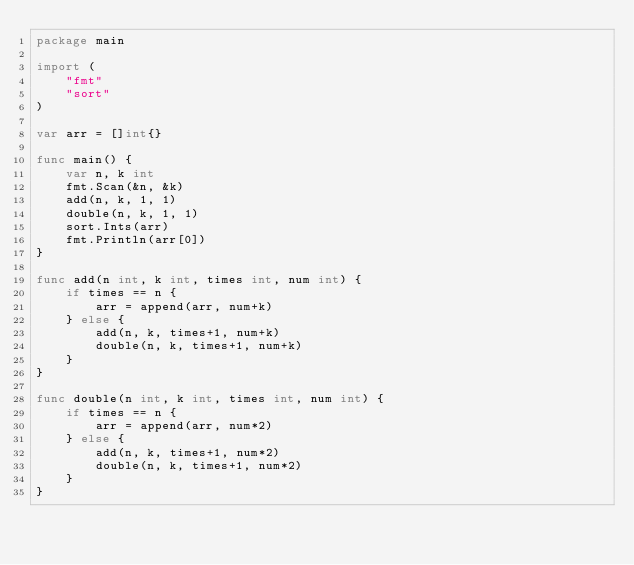Convert code to text. <code><loc_0><loc_0><loc_500><loc_500><_Go_>package main

import (
	"fmt"
	"sort"
)

var arr = []int{}

func main() {
	var n, k int
	fmt.Scan(&n, &k)
	add(n, k, 1, 1)
	double(n, k, 1, 1)
	sort.Ints(arr)
	fmt.Println(arr[0])
}

func add(n int, k int, times int, num int) {
	if times == n {
		arr = append(arr, num+k)
	} else {
		add(n, k, times+1, num+k)
		double(n, k, times+1, num+k)
	}
}

func double(n int, k int, times int, num int) {
	if times == n {
		arr = append(arr, num*2)
	} else {
		add(n, k, times+1, num*2)
		double(n, k, times+1, num*2)
	}
}</code> 